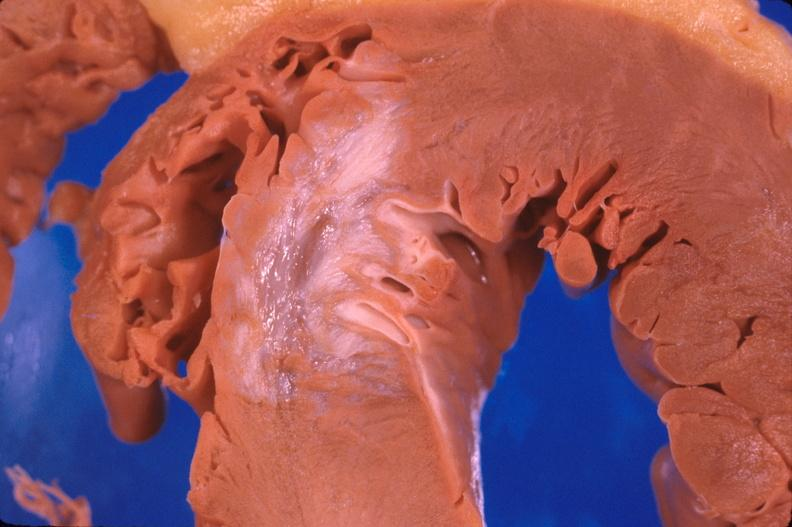s cardiovascular present?
Answer the question using a single word or phrase. Yes 